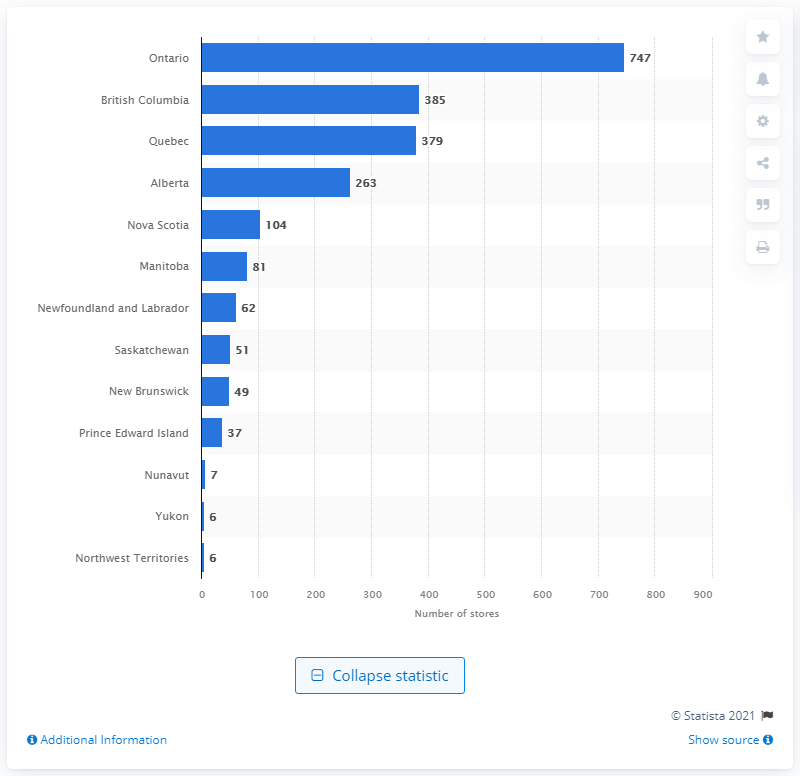Identify some key points in this picture. As of December 2020, there were 747 gift, novelty, and souvenir stores located in Ontario. 